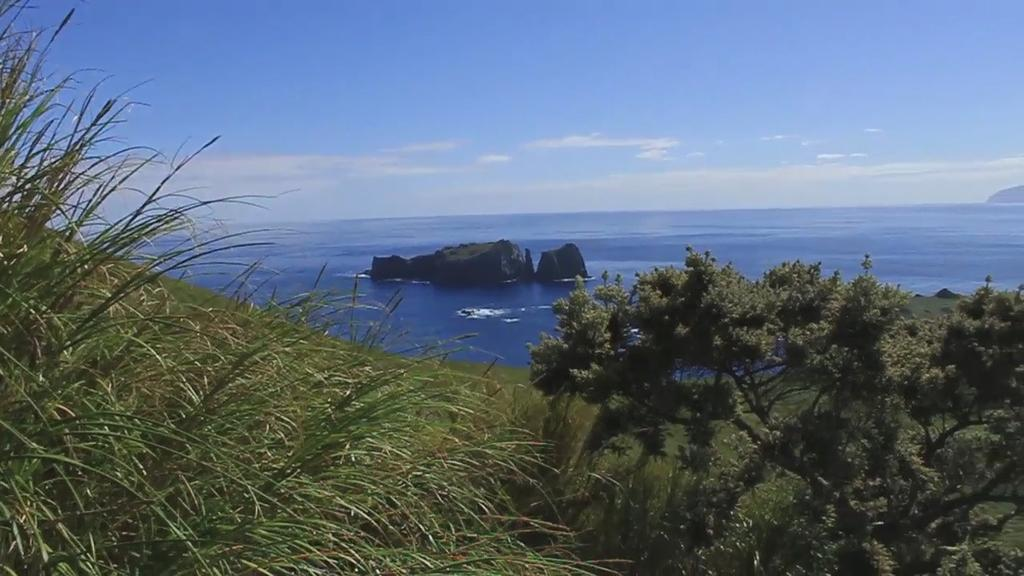What type of vegetation can be seen in the image? There are plants, trees, and grass in the image. What is the terrain feature in the middle of the image? There is a hill in the middle of the image. What is the location of the hill in relation to the ocean? The hill is in the middle of the ocean. What is visible in the sky in the image? The sky is visible in the image, and clouds are present. What type of industry can be seen operating on the hill in the image? There is no industry present in the image; it features a hill in the middle of the ocean with vegetation and a sky with clouds. How does the screw move around in the image? There is no screw present in the image, so it cannot move around. 